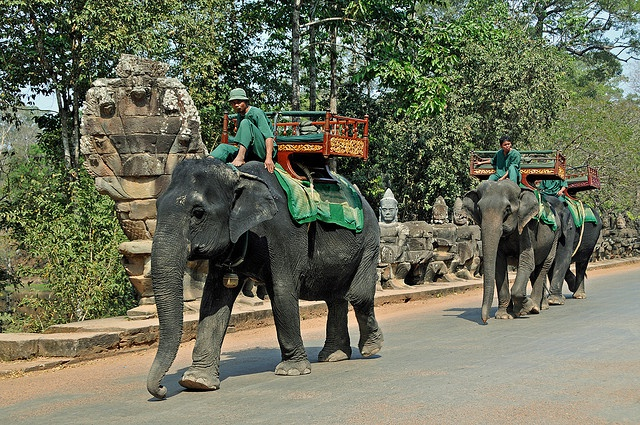Describe the objects in this image and their specific colors. I can see elephant in black and gray tones, elephant in black, gray, and darkgray tones, elephant in black, gray, and darkgray tones, people in black and teal tones, and people in black, teal, and gray tones in this image. 